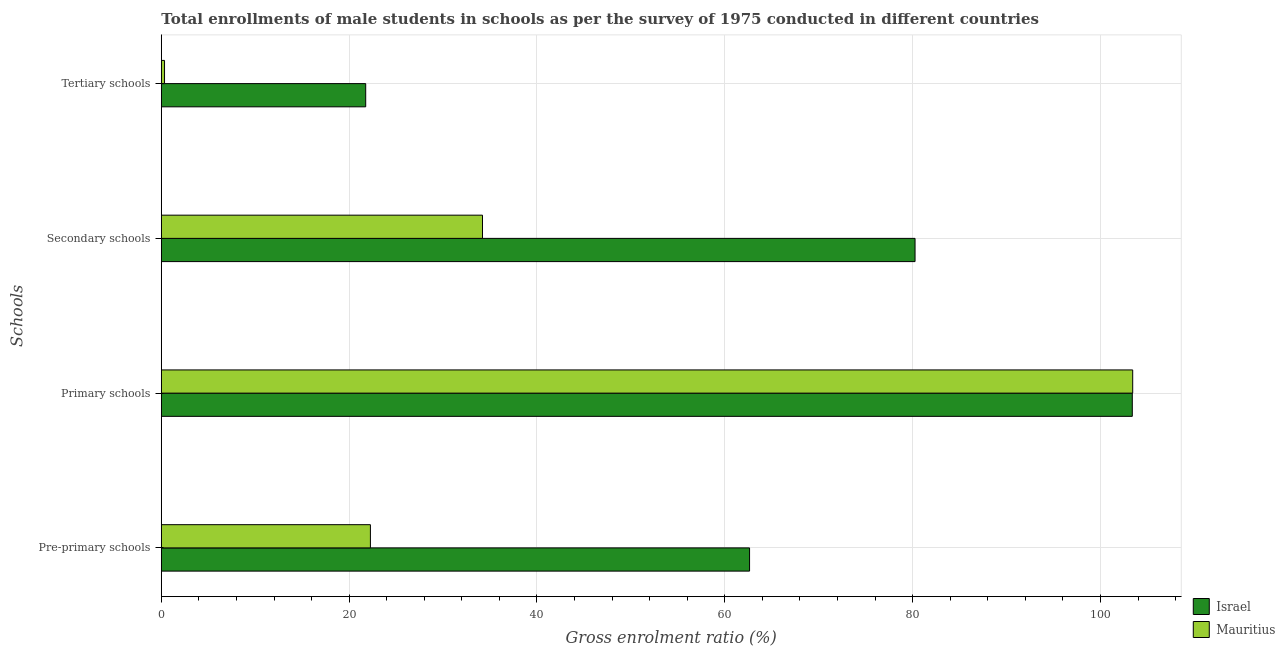How many groups of bars are there?
Your answer should be compact. 4. How many bars are there on the 3rd tick from the top?
Give a very brief answer. 2. How many bars are there on the 1st tick from the bottom?
Keep it short and to the point. 2. What is the label of the 2nd group of bars from the top?
Your answer should be compact. Secondary schools. What is the gross enrolment ratio(male) in primary schools in Mauritius?
Make the answer very short. 103.43. Across all countries, what is the maximum gross enrolment ratio(male) in pre-primary schools?
Your response must be concise. 62.63. Across all countries, what is the minimum gross enrolment ratio(male) in primary schools?
Offer a terse response. 103.39. In which country was the gross enrolment ratio(male) in pre-primary schools minimum?
Give a very brief answer. Mauritius. What is the total gross enrolment ratio(male) in primary schools in the graph?
Offer a very short reply. 206.82. What is the difference between the gross enrolment ratio(male) in tertiary schools in Israel and that in Mauritius?
Provide a succinct answer. 21.42. What is the difference between the gross enrolment ratio(male) in secondary schools in Israel and the gross enrolment ratio(male) in primary schools in Mauritius?
Ensure brevity in your answer.  -23.17. What is the average gross enrolment ratio(male) in primary schools per country?
Provide a short and direct response. 103.41. What is the difference between the gross enrolment ratio(male) in secondary schools and gross enrolment ratio(male) in pre-primary schools in Mauritius?
Give a very brief answer. 11.94. In how many countries, is the gross enrolment ratio(male) in tertiary schools greater than 56 %?
Provide a succinct answer. 0. What is the ratio of the gross enrolment ratio(male) in secondary schools in Mauritius to that in Israel?
Keep it short and to the point. 0.43. Is the difference between the gross enrolment ratio(male) in tertiary schools in Mauritius and Israel greater than the difference between the gross enrolment ratio(male) in secondary schools in Mauritius and Israel?
Your answer should be very brief. Yes. What is the difference between the highest and the second highest gross enrolment ratio(male) in pre-primary schools?
Ensure brevity in your answer.  40.37. What is the difference between the highest and the lowest gross enrolment ratio(male) in pre-primary schools?
Ensure brevity in your answer.  40.37. Is the sum of the gross enrolment ratio(male) in pre-primary schools in Israel and Mauritius greater than the maximum gross enrolment ratio(male) in tertiary schools across all countries?
Your answer should be compact. Yes. Is it the case that in every country, the sum of the gross enrolment ratio(male) in primary schools and gross enrolment ratio(male) in pre-primary schools is greater than the sum of gross enrolment ratio(male) in tertiary schools and gross enrolment ratio(male) in secondary schools?
Offer a terse response. Yes. What does the 1st bar from the top in Tertiary schools represents?
Your response must be concise. Mauritius. What does the 2nd bar from the bottom in Pre-primary schools represents?
Offer a very short reply. Mauritius. Is it the case that in every country, the sum of the gross enrolment ratio(male) in pre-primary schools and gross enrolment ratio(male) in primary schools is greater than the gross enrolment ratio(male) in secondary schools?
Your response must be concise. Yes. How many bars are there?
Offer a very short reply. 8. Are all the bars in the graph horizontal?
Ensure brevity in your answer.  Yes. How many countries are there in the graph?
Your answer should be compact. 2. How many legend labels are there?
Your answer should be compact. 2. What is the title of the graph?
Provide a succinct answer. Total enrollments of male students in schools as per the survey of 1975 conducted in different countries. What is the label or title of the X-axis?
Your response must be concise. Gross enrolment ratio (%). What is the label or title of the Y-axis?
Keep it short and to the point. Schools. What is the Gross enrolment ratio (%) of Israel in Pre-primary schools?
Your answer should be very brief. 62.63. What is the Gross enrolment ratio (%) of Mauritius in Pre-primary schools?
Provide a succinct answer. 22.26. What is the Gross enrolment ratio (%) in Israel in Primary schools?
Provide a succinct answer. 103.39. What is the Gross enrolment ratio (%) in Mauritius in Primary schools?
Your answer should be compact. 103.43. What is the Gross enrolment ratio (%) in Israel in Secondary schools?
Give a very brief answer. 80.26. What is the Gross enrolment ratio (%) in Mauritius in Secondary schools?
Ensure brevity in your answer.  34.2. What is the Gross enrolment ratio (%) in Israel in Tertiary schools?
Keep it short and to the point. 21.76. What is the Gross enrolment ratio (%) in Mauritius in Tertiary schools?
Your response must be concise. 0.34. Across all Schools, what is the maximum Gross enrolment ratio (%) of Israel?
Your response must be concise. 103.39. Across all Schools, what is the maximum Gross enrolment ratio (%) in Mauritius?
Offer a terse response. 103.43. Across all Schools, what is the minimum Gross enrolment ratio (%) in Israel?
Ensure brevity in your answer.  21.76. Across all Schools, what is the minimum Gross enrolment ratio (%) in Mauritius?
Provide a short and direct response. 0.34. What is the total Gross enrolment ratio (%) in Israel in the graph?
Provide a short and direct response. 268.04. What is the total Gross enrolment ratio (%) of Mauritius in the graph?
Offer a terse response. 160.24. What is the difference between the Gross enrolment ratio (%) of Israel in Pre-primary schools and that in Primary schools?
Your response must be concise. -40.75. What is the difference between the Gross enrolment ratio (%) of Mauritius in Pre-primary schools and that in Primary schools?
Offer a terse response. -81.17. What is the difference between the Gross enrolment ratio (%) of Israel in Pre-primary schools and that in Secondary schools?
Provide a succinct answer. -17.62. What is the difference between the Gross enrolment ratio (%) in Mauritius in Pre-primary schools and that in Secondary schools?
Ensure brevity in your answer.  -11.94. What is the difference between the Gross enrolment ratio (%) of Israel in Pre-primary schools and that in Tertiary schools?
Your answer should be very brief. 40.87. What is the difference between the Gross enrolment ratio (%) in Mauritius in Pre-primary schools and that in Tertiary schools?
Your answer should be very brief. 21.92. What is the difference between the Gross enrolment ratio (%) in Israel in Primary schools and that in Secondary schools?
Provide a succinct answer. 23.13. What is the difference between the Gross enrolment ratio (%) in Mauritius in Primary schools and that in Secondary schools?
Your answer should be very brief. 69.23. What is the difference between the Gross enrolment ratio (%) of Israel in Primary schools and that in Tertiary schools?
Give a very brief answer. 81.62. What is the difference between the Gross enrolment ratio (%) of Mauritius in Primary schools and that in Tertiary schools?
Offer a very short reply. 103.09. What is the difference between the Gross enrolment ratio (%) of Israel in Secondary schools and that in Tertiary schools?
Ensure brevity in your answer.  58.49. What is the difference between the Gross enrolment ratio (%) of Mauritius in Secondary schools and that in Tertiary schools?
Keep it short and to the point. 33.86. What is the difference between the Gross enrolment ratio (%) in Israel in Pre-primary schools and the Gross enrolment ratio (%) in Mauritius in Primary schools?
Provide a succinct answer. -40.8. What is the difference between the Gross enrolment ratio (%) of Israel in Pre-primary schools and the Gross enrolment ratio (%) of Mauritius in Secondary schools?
Provide a short and direct response. 28.43. What is the difference between the Gross enrolment ratio (%) in Israel in Pre-primary schools and the Gross enrolment ratio (%) in Mauritius in Tertiary schools?
Your answer should be very brief. 62.29. What is the difference between the Gross enrolment ratio (%) of Israel in Primary schools and the Gross enrolment ratio (%) of Mauritius in Secondary schools?
Your response must be concise. 69.19. What is the difference between the Gross enrolment ratio (%) in Israel in Primary schools and the Gross enrolment ratio (%) in Mauritius in Tertiary schools?
Make the answer very short. 103.05. What is the difference between the Gross enrolment ratio (%) in Israel in Secondary schools and the Gross enrolment ratio (%) in Mauritius in Tertiary schools?
Provide a short and direct response. 79.91. What is the average Gross enrolment ratio (%) in Israel per Schools?
Make the answer very short. 67.01. What is the average Gross enrolment ratio (%) in Mauritius per Schools?
Ensure brevity in your answer.  40.06. What is the difference between the Gross enrolment ratio (%) of Israel and Gross enrolment ratio (%) of Mauritius in Pre-primary schools?
Provide a succinct answer. 40.37. What is the difference between the Gross enrolment ratio (%) in Israel and Gross enrolment ratio (%) in Mauritius in Primary schools?
Give a very brief answer. -0.04. What is the difference between the Gross enrolment ratio (%) in Israel and Gross enrolment ratio (%) in Mauritius in Secondary schools?
Give a very brief answer. 46.06. What is the difference between the Gross enrolment ratio (%) of Israel and Gross enrolment ratio (%) of Mauritius in Tertiary schools?
Offer a very short reply. 21.42. What is the ratio of the Gross enrolment ratio (%) of Israel in Pre-primary schools to that in Primary schools?
Your answer should be very brief. 0.61. What is the ratio of the Gross enrolment ratio (%) in Mauritius in Pre-primary schools to that in Primary schools?
Offer a terse response. 0.22. What is the ratio of the Gross enrolment ratio (%) in Israel in Pre-primary schools to that in Secondary schools?
Ensure brevity in your answer.  0.78. What is the ratio of the Gross enrolment ratio (%) in Mauritius in Pre-primary schools to that in Secondary schools?
Offer a terse response. 0.65. What is the ratio of the Gross enrolment ratio (%) in Israel in Pre-primary schools to that in Tertiary schools?
Make the answer very short. 2.88. What is the ratio of the Gross enrolment ratio (%) in Mauritius in Pre-primary schools to that in Tertiary schools?
Give a very brief answer. 65.15. What is the ratio of the Gross enrolment ratio (%) in Israel in Primary schools to that in Secondary schools?
Give a very brief answer. 1.29. What is the ratio of the Gross enrolment ratio (%) of Mauritius in Primary schools to that in Secondary schools?
Your response must be concise. 3.02. What is the ratio of the Gross enrolment ratio (%) of Israel in Primary schools to that in Tertiary schools?
Provide a succinct answer. 4.75. What is the ratio of the Gross enrolment ratio (%) in Mauritius in Primary schools to that in Tertiary schools?
Offer a very short reply. 302.66. What is the ratio of the Gross enrolment ratio (%) in Israel in Secondary schools to that in Tertiary schools?
Provide a short and direct response. 3.69. What is the ratio of the Gross enrolment ratio (%) in Mauritius in Secondary schools to that in Tertiary schools?
Provide a succinct answer. 100.07. What is the difference between the highest and the second highest Gross enrolment ratio (%) of Israel?
Ensure brevity in your answer.  23.13. What is the difference between the highest and the second highest Gross enrolment ratio (%) in Mauritius?
Your response must be concise. 69.23. What is the difference between the highest and the lowest Gross enrolment ratio (%) in Israel?
Offer a very short reply. 81.62. What is the difference between the highest and the lowest Gross enrolment ratio (%) of Mauritius?
Your answer should be compact. 103.09. 